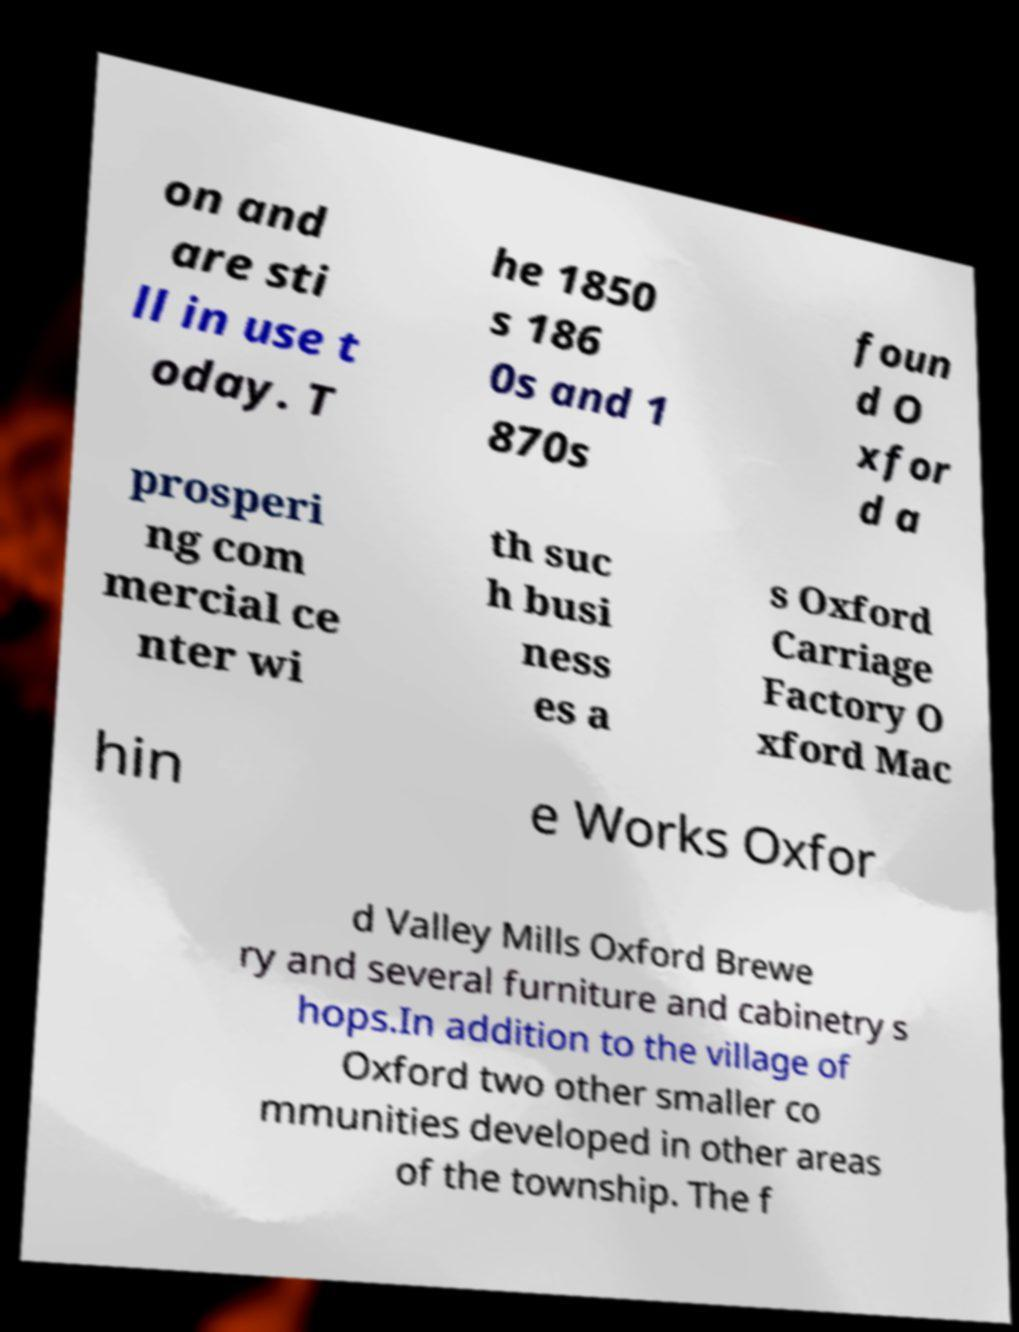Could you extract and type out the text from this image? on and are sti ll in use t oday. T he 1850 s 186 0s and 1 870s foun d O xfor d a prosperi ng com mercial ce nter wi th suc h busi ness es a s Oxford Carriage Factory O xford Mac hin e Works Oxfor d Valley Mills Oxford Brewe ry and several furniture and cabinetry s hops.In addition to the village of Oxford two other smaller co mmunities developed in other areas of the township. The f 